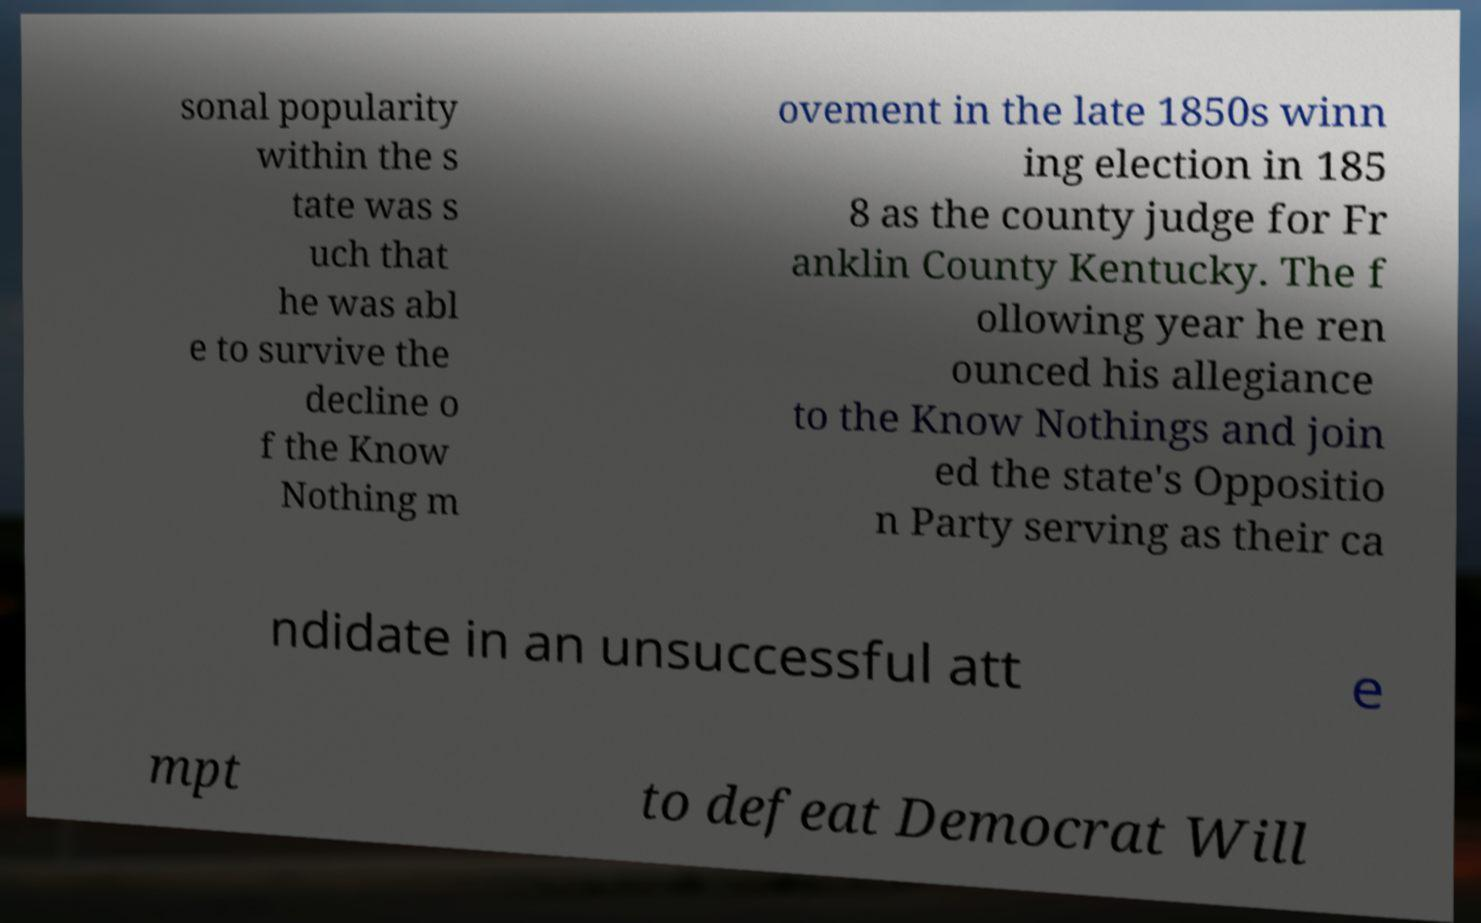Please read and relay the text visible in this image. What does it say? sonal popularity within the s tate was s uch that he was abl e to survive the decline o f the Know Nothing m ovement in the late 1850s winn ing election in 185 8 as the county judge for Fr anklin County Kentucky. The f ollowing year he ren ounced his allegiance to the Know Nothings and join ed the state's Oppositio n Party serving as their ca ndidate in an unsuccessful att e mpt to defeat Democrat Will 